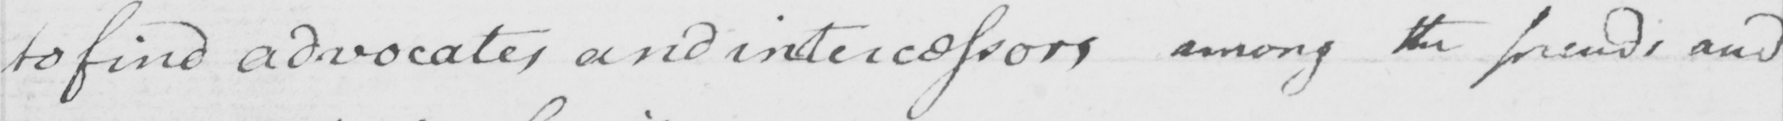What does this handwritten line say? to find advocates and intercessors among the friends and 